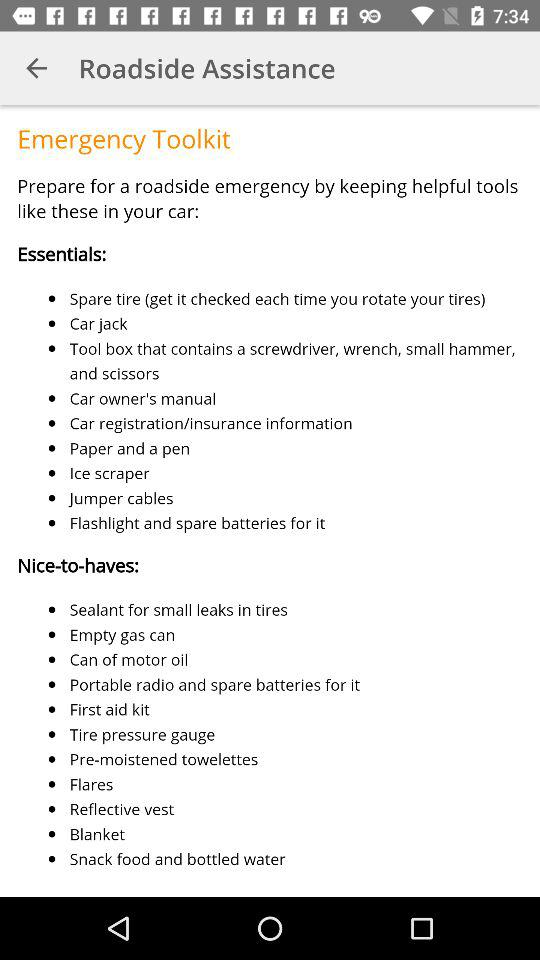How can I prepare for a roadside emergency? You can prepare for a roadside emergency by keeping helpful tools in your car. 